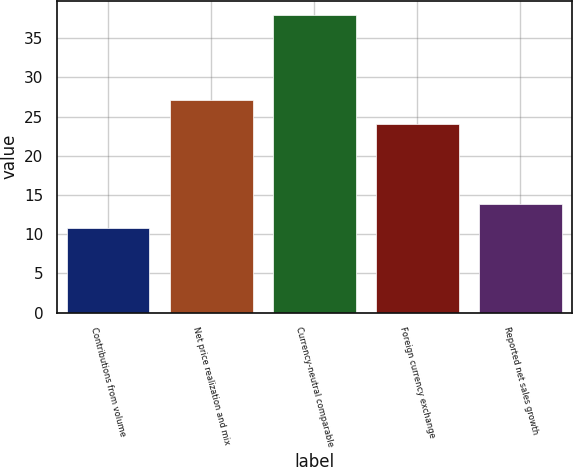Convert chart. <chart><loc_0><loc_0><loc_500><loc_500><bar_chart><fcel>Contributions from volume<fcel>Net price realization and mix<fcel>Currency-neutral comparable<fcel>Foreign currency exchange<fcel>Reported net sales growth<nl><fcel>10.8<fcel>27.1<fcel>37.9<fcel>24<fcel>13.9<nl></chart> 